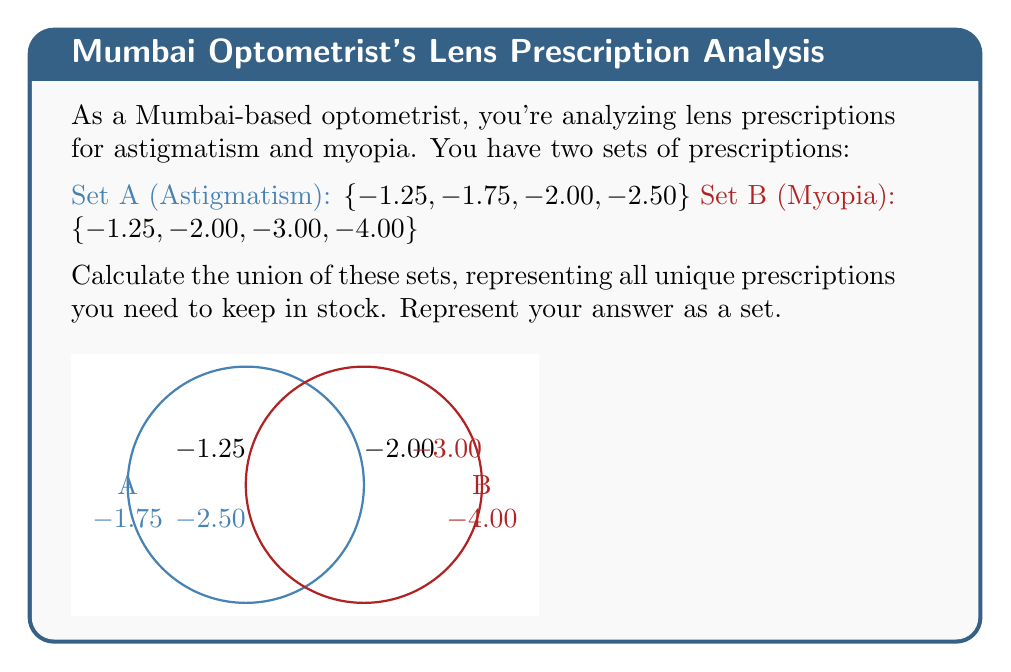Provide a solution to this math problem. To find the union of sets A and B, we need to combine all unique elements from both sets. Let's approach this step-by-step:

1) First, let's list out all elements from both sets:
   Set A: $\{-1.25, -1.75, -2.00, -2.50\}$
   Set B: $\{-1.25, -2.00, -3.00, -4.00\}$

2) Now, we need to identify all unique elements. We can do this by listing each element once, even if it appears in both sets:

   $-1.25$ (appears in both A and B)
   $-1.75$ (appears only in A)
   $-2.00$ (appears in both A and B)
   $-2.50$ (appears only in A)
   $-3.00$ (appears only in B)
   $-4.00$ (appears only in B)

3) The union of A and B, denoted as $A \cup B$, is the set of all these unique elements.

4) We can write this as a set:
   $A \cup B = \{-1.25, -1.75, -2.00, -2.50, -3.00, -4.00\}$

This set represents all unique prescriptions you need to keep in stock to cover both astigmatism and myopia cases.
Answer: $\{-1.25, -1.75, -2.00, -2.50, -3.00, -4.00\}$ 